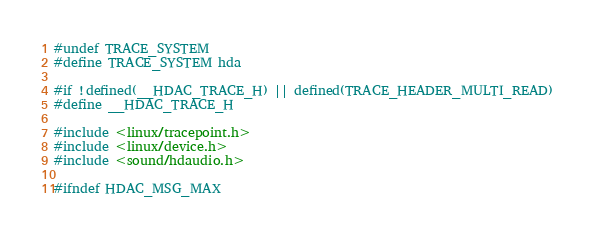<code> <loc_0><loc_0><loc_500><loc_500><_C_>#undef TRACE_SYSTEM
#define TRACE_SYSTEM hda

#if !defined(__HDAC_TRACE_H) || defined(TRACE_HEADER_MULTI_READ)
#define __HDAC_TRACE_H

#include <linux/tracepoint.h>
#include <linux/device.h>
#include <sound/hdaudio.h>

#ifndef HDAC_MSG_MAX</code> 